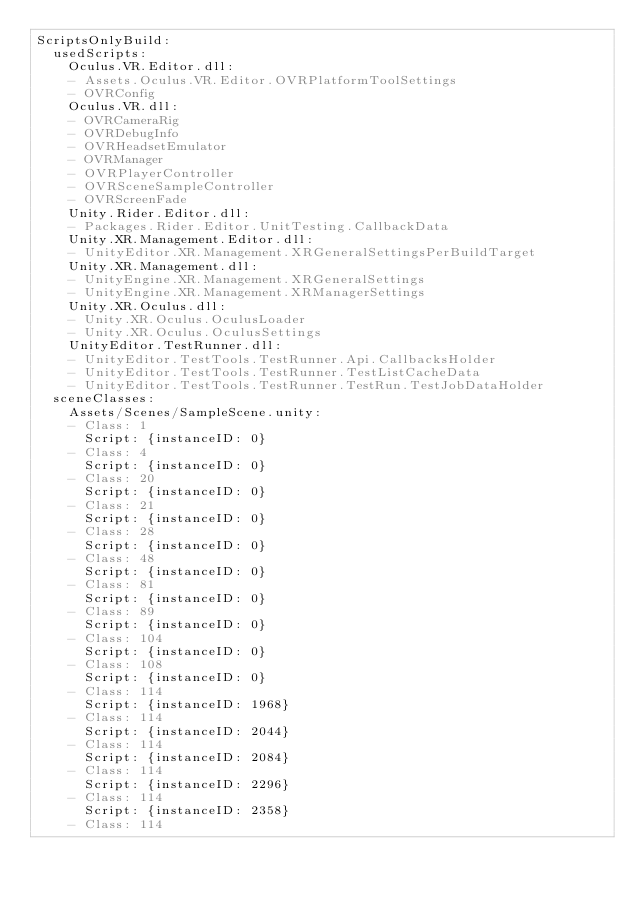Convert code to text. <code><loc_0><loc_0><loc_500><loc_500><_YAML_>ScriptsOnlyBuild:
  usedScripts:
    Oculus.VR.Editor.dll:
    - Assets.Oculus.VR.Editor.OVRPlatformToolSettings
    - OVRConfig
    Oculus.VR.dll:
    - OVRCameraRig
    - OVRDebugInfo
    - OVRHeadsetEmulator
    - OVRManager
    - OVRPlayerController
    - OVRSceneSampleController
    - OVRScreenFade
    Unity.Rider.Editor.dll:
    - Packages.Rider.Editor.UnitTesting.CallbackData
    Unity.XR.Management.Editor.dll:
    - UnityEditor.XR.Management.XRGeneralSettingsPerBuildTarget
    Unity.XR.Management.dll:
    - UnityEngine.XR.Management.XRGeneralSettings
    - UnityEngine.XR.Management.XRManagerSettings
    Unity.XR.Oculus.dll:
    - Unity.XR.Oculus.OculusLoader
    - Unity.XR.Oculus.OculusSettings
    UnityEditor.TestRunner.dll:
    - UnityEditor.TestTools.TestRunner.Api.CallbacksHolder
    - UnityEditor.TestTools.TestRunner.TestListCacheData
    - UnityEditor.TestTools.TestRunner.TestRun.TestJobDataHolder
  sceneClasses:
    Assets/Scenes/SampleScene.unity:
    - Class: 1
      Script: {instanceID: 0}
    - Class: 4
      Script: {instanceID: 0}
    - Class: 20
      Script: {instanceID: 0}
    - Class: 21
      Script: {instanceID: 0}
    - Class: 28
      Script: {instanceID: 0}
    - Class: 48
      Script: {instanceID: 0}
    - Class: 81
      Script: {instanceID: 0}
    - Class: 89
      Script: {instanceID: 0}
    - Class: 104
      Script: {instanceID: 0}
    - Class: 108
      Script: {instanceID: 0}
    - Class: 114
      Script: {instanceID: 1968}
    - Class: 114
      Script: {instanceID: 2044}
    - Class: 114
      Script: {instanceID: 2084}
    - Class: 114
      Script: {instanceID: 2296}
    - Class: 114
      Script: {instanceID: 2358}
    - Class: 114</code> 